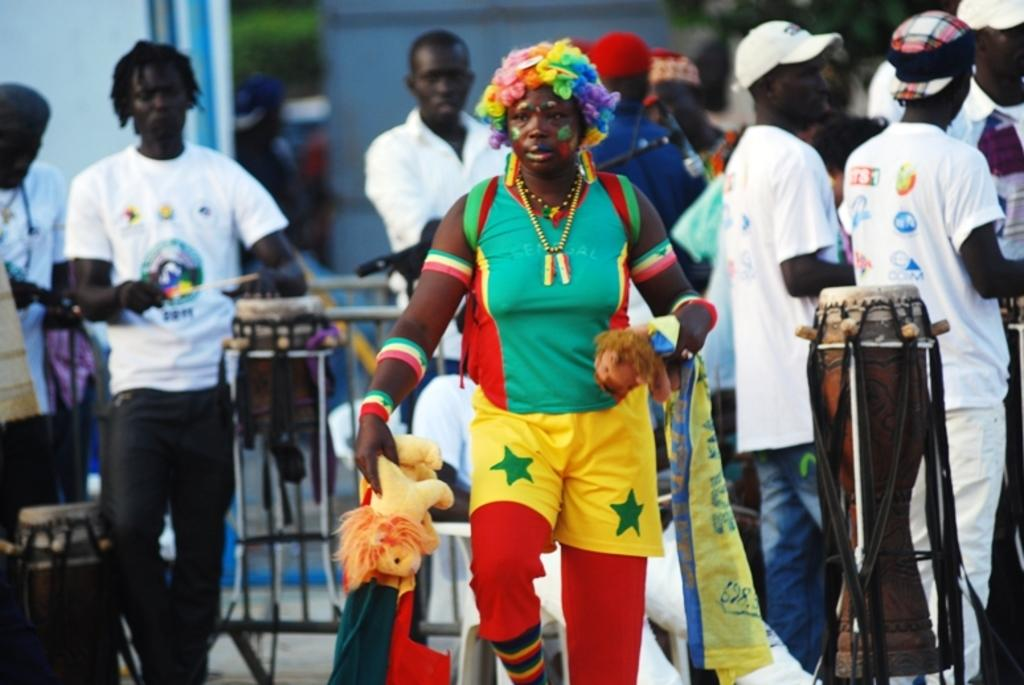How many people are in the image? The number of people in the image is not specified, but there are people present. What is the location of the people in the image? The people are standing on the road in the image. What type of cord is being used by the people in the image? There is no mention of a cord in the image, so it cannot be determined if any cord is being used. 